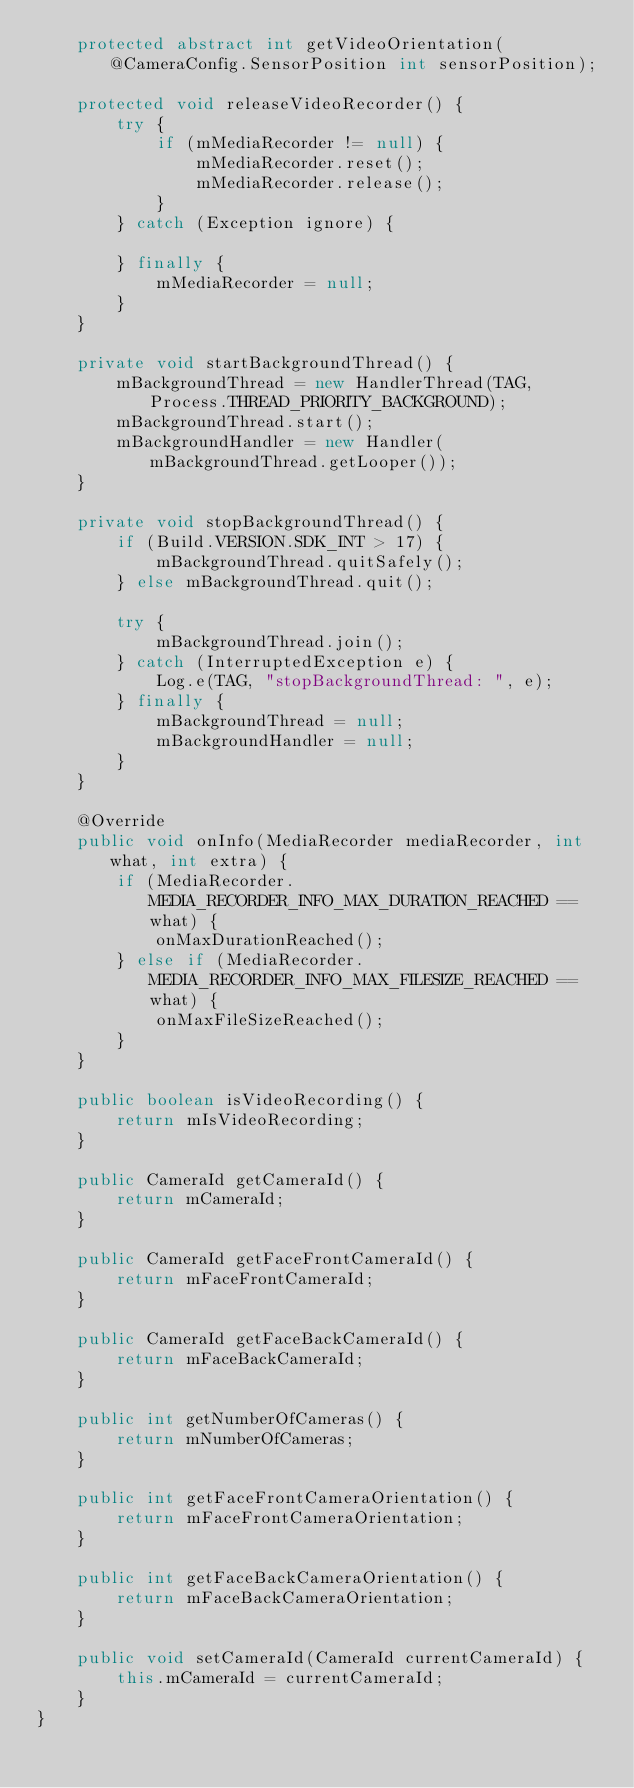Convert code to text. <code><loc_0><loc_0><loc_500><loc_500><_Java_>    protected abstract int getVideoOrientation(@CameraConfig.SensorPosition int sensorPosition);

    protected void releaseVideoRecorder() {
        try {
            if (mMediaRecorder != null) {
                mMediaRecorder.reset();
                mMediaRecorder.release();
            }
        } catch (Exception ignore) {

        } finally {
            mMediaRecorder = null;
        }
    }

    private void startBackgroundThread() {
        mBackgroundThread = new HandlerThread(TAG, Process.THREAD_PRIORITY_BACKGROUND);
        mBackgroundThread.start();
        mBackgroundHandler = new Handler(mBackgroundThread.getLooper());
    }

    private void stopBackgroundThread() {
        if (Build.VERSION.SDK_INT > 17) {
            mBackgroundThread.quitSafely();
        } else mBackgroundThread.quit();

        try {
            mBackgroundThread.join();
        } catch (InterruptedException e) {
            Log.e(TAG, "stopBackgroundThread: ", e);
        } finally {
            mBackgroundThread = null;
            mBackgroundHandler = null;
        }
    }

    @Override
    public void onInfo(MediaRecorder mediaRecorder, int what, int extra) {
        if (MediaRecorder.MEDIA_RECORDER_INFO_MAX_DURATION_REACHED == what) {
            onMaxDurationReached();
        } else if (MediaRecorder.MEDIA_RECORDER_INFO_MAX_FILESIZE_REACHED == what) {
            onMaxFileSizeReached();
        }
    }

    public boolean isVideoRecording() {
        return mIsVideoRecording;
    }

    public CameraId getCameraId() {
        return mCameraId;
    }

    public CameraId getFaceFrontCameraId() {
        return mFaceFrontCameraId;
    }

    public CameraId getFaceBackCameraId() {
        return mFaceBackCameraId;
    }

    public int getNumberOfCameras() {
        return mNumberOfCameras;
    }

    public int getFaceFrontCameraOrientation() {
        return mFaceFrontCameraOrientation;
    }

    public int getFaceBackCameraOrientation() {
        return mFaceBackCameraOrientation;
    }

    public void setCameraId(CameraId currentCameraId) {
        this.mCameraId = currentCameraId;
    }
}
</code> 